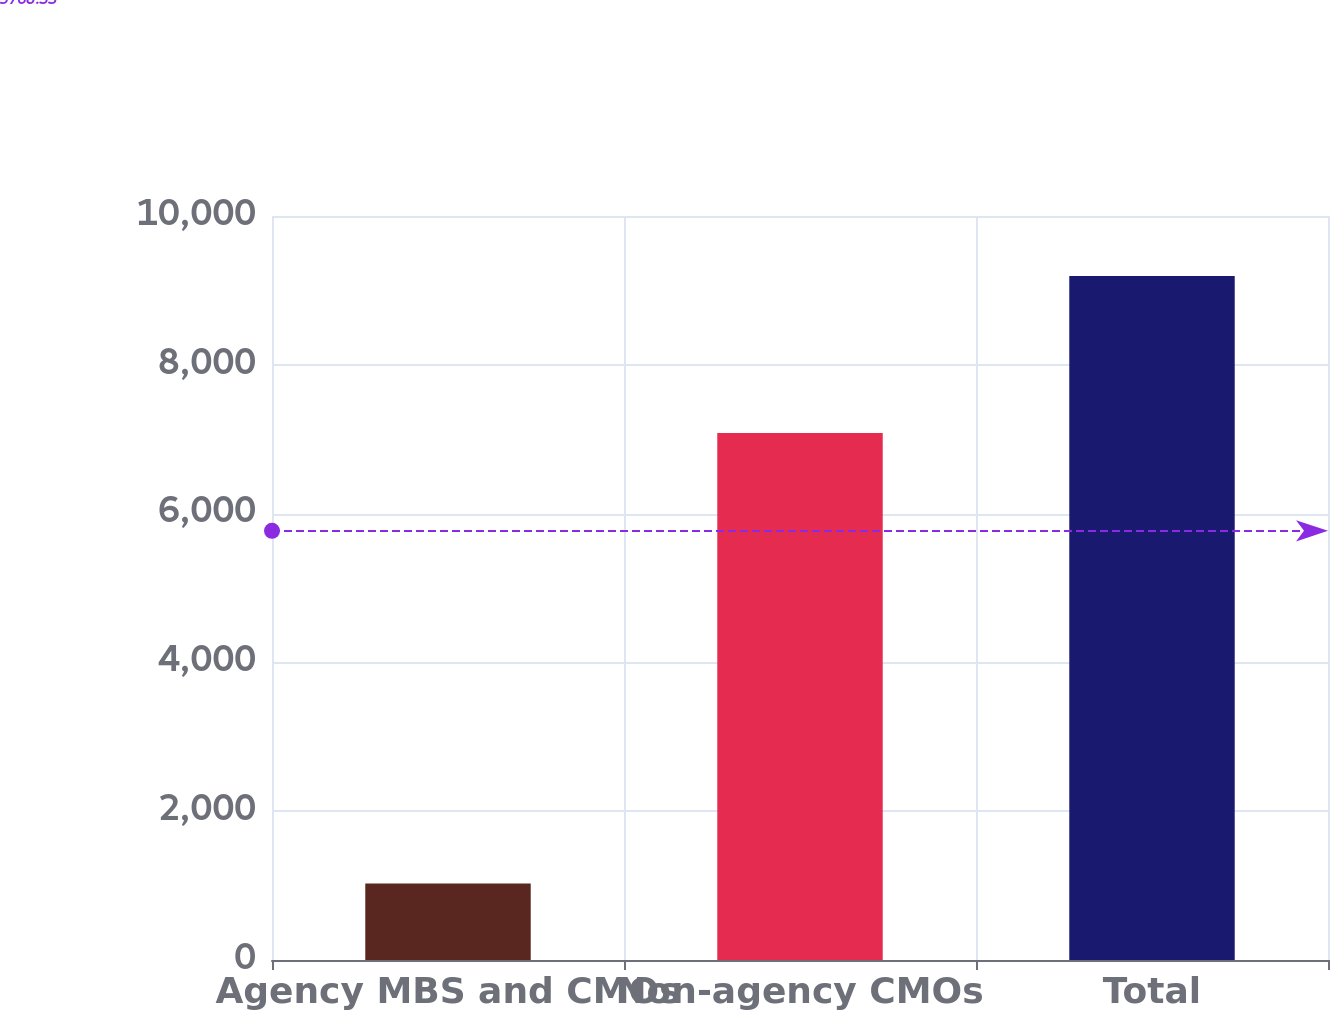Convert chart. <chart><loc_0><loc_0><loc_500><loc_500><bar_chart><fcel>Agency MBS and CMOs<fcel>Non-agency CMOs<fcel>Total<nl><fcel>1029<fcel>7084<fcel>9192<nl></chart> 